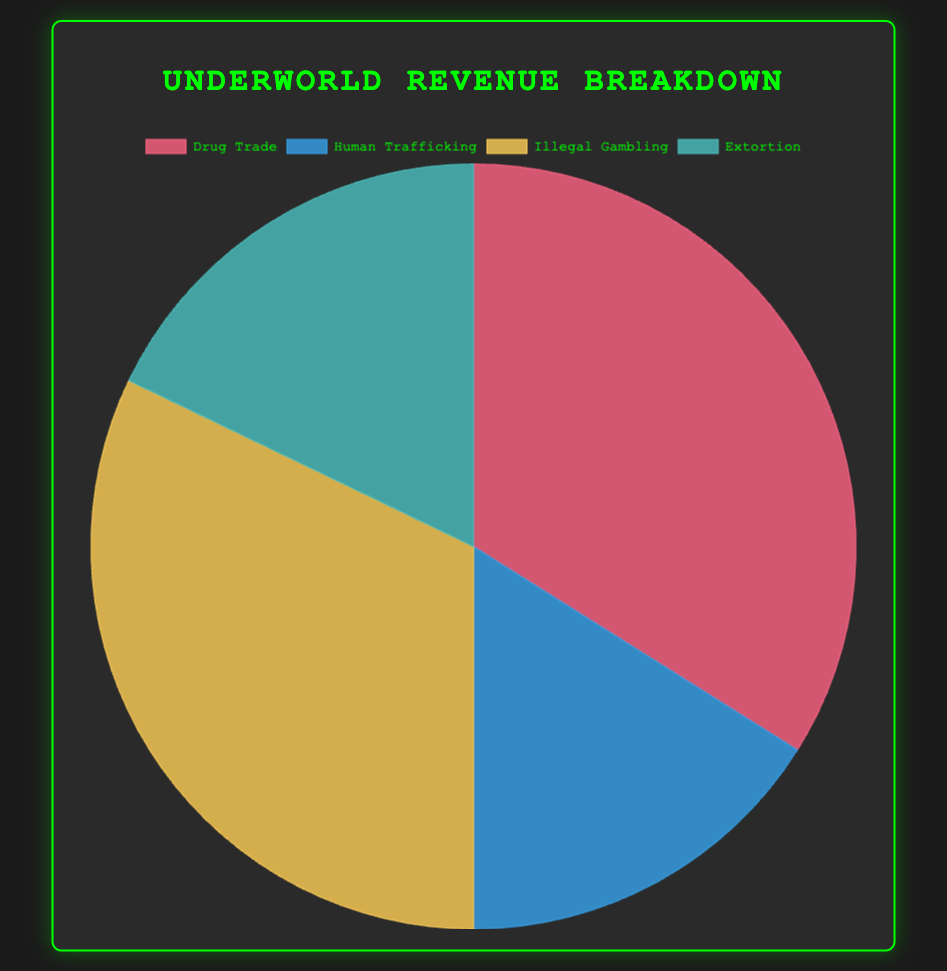Which illegal activity generates the highest revenue? The pie chart segments depict the total revenues for various illegal activities. The segment with the largest area represents the activity with the highest revenue.
Answer: Drug Trade Among Illegal Gambling and Extortion, which activity generates more revenue, and by how much? Comparing the two segments visually, Illegal Gambling’s segment appears larger. To find the difference, subtract Extortion's total revenue from Illegal Gambling's total revenue: $9,000,000 - $5,000,000.
Answer: Illegal Gambling, by $4,000,000 How much total revenue is generated by all activities combined? Sum the revenues of all segments: $9,000,000 (Drug Trade) + $4,500,000 (Human Trafficking) + $9,000,000 (Illegal Gambling) + $5,000,000 (Extortion) equals $27,500,000.
Answer: $27,500,000 What is the average revenue per activity? First, find the total revenue: $27,500,000. Then divide by the number of activities: $27,500,000 / 4.
Answer: $6,875,000 Which illegal activities have revenues within $500,000 of $5,000,000? Human Trafficking and Extortion each have segments visually resembling $5,000,000. Human Trafficking: $4,500,000 and Extortion: $5,000,000. Both are within $500,000 of the target.
Answer: Human Trafficking, Extortion What percentage of the total revenue is generated by Human Trafficking? First calculate the total revenue ($27,500,000). Then find the percentage: ($4,500,000 / $27,500,000) * 100 = 16.36%.
Answer: 16.36% Which activities’ revenues fall below the overall total average? First find the average revenue: $6,875,000. Then compare each activity. Human Trafficking ($4,500,000) and Extortion ($5,000,000) are below this average.
Answer: Human Trafficking, Extortion How does the revenue from Human Trafficking compare to Online Gambling Sites under Illegal Gambling? Human Trafficking's total revenue: $4,500,000. Online Gambling Sites revenue is $3,000,000. By checking the areas in the pie, Human Trafficking’s revenue is greater.
Answer: Human Trafficking If Cartel Operations under Drug Trade were eliminated, what would the new total Drug Trade revenue be, and how would it compare to Illegal Gambling? Drug Trade without Cartel Operations: $9,000,000 - $5,000,000 = $4,000,000. Illegal Gambling revenue is $9,000,000, which is larger.
Answer: $4,000,000; Illegal Gambling is larger 